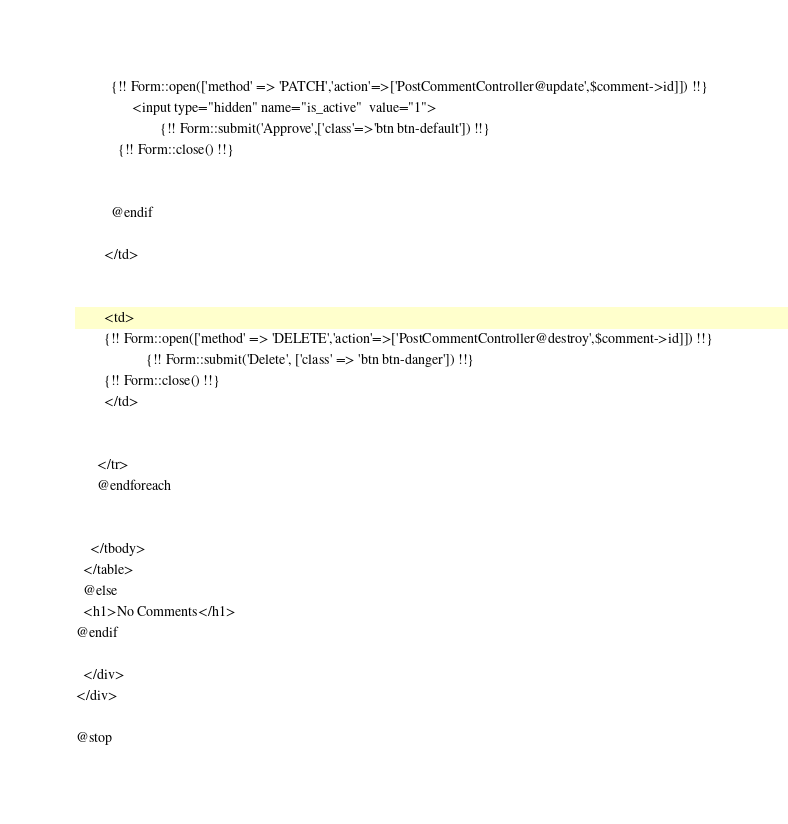Convert code to text. <code><loc_0><loc_0><loc_500><loc_500><_PHP_>
          {!! Form::open(['method' => 'PATCH','action'=>['PostCommentController@update',$comment->id]]) !!}
                <input type="hidden" name="is_active"  value="1">
                        {!! Form::submit('Approve',['class'=>'btn btn-default']) !!}        
            {!! Form::close() !!}


          @endif

        </td>


        <td>
        {!! Form::open(['method' => 'DELETE','action'=>['PostCommentController@destroy',$comment->id]]) !!}
                    {!! Form::submit('Delete', ['class' => 'btn btn-danger']) !!}        
        {!! Form::close() !!}
        </td>


      </tr>
      @endforeach


    </tbody>
  </table>
  @else
  <h1>No Comments</h1>
@endif

  </div>
</div>

@stop</code> 